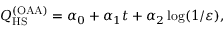<formula> <loc_0><loc_0><loc_500><loc_500>Q _ { H S } ^ { ( O A A ) } = \alpha _ { 0 } + \alpha _ { 1 } t + \alpha _ { 2 } \log ( 1 / \varepsilon ) ,</formula> 